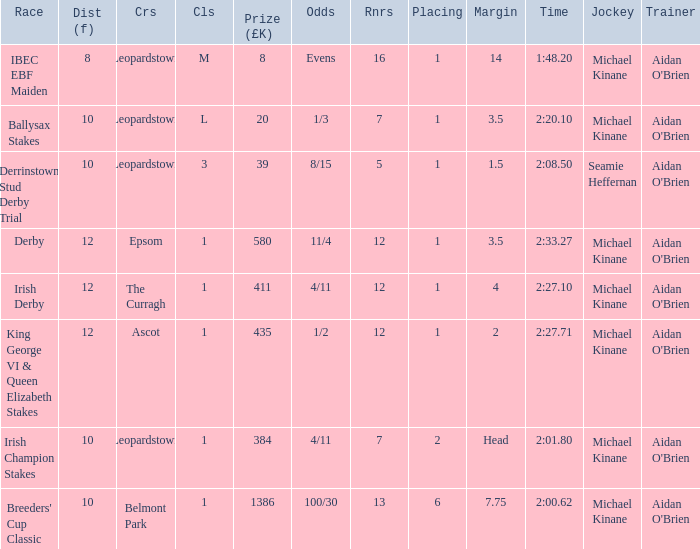Which Dist (f) has a Race of irish derby? 12.0. 